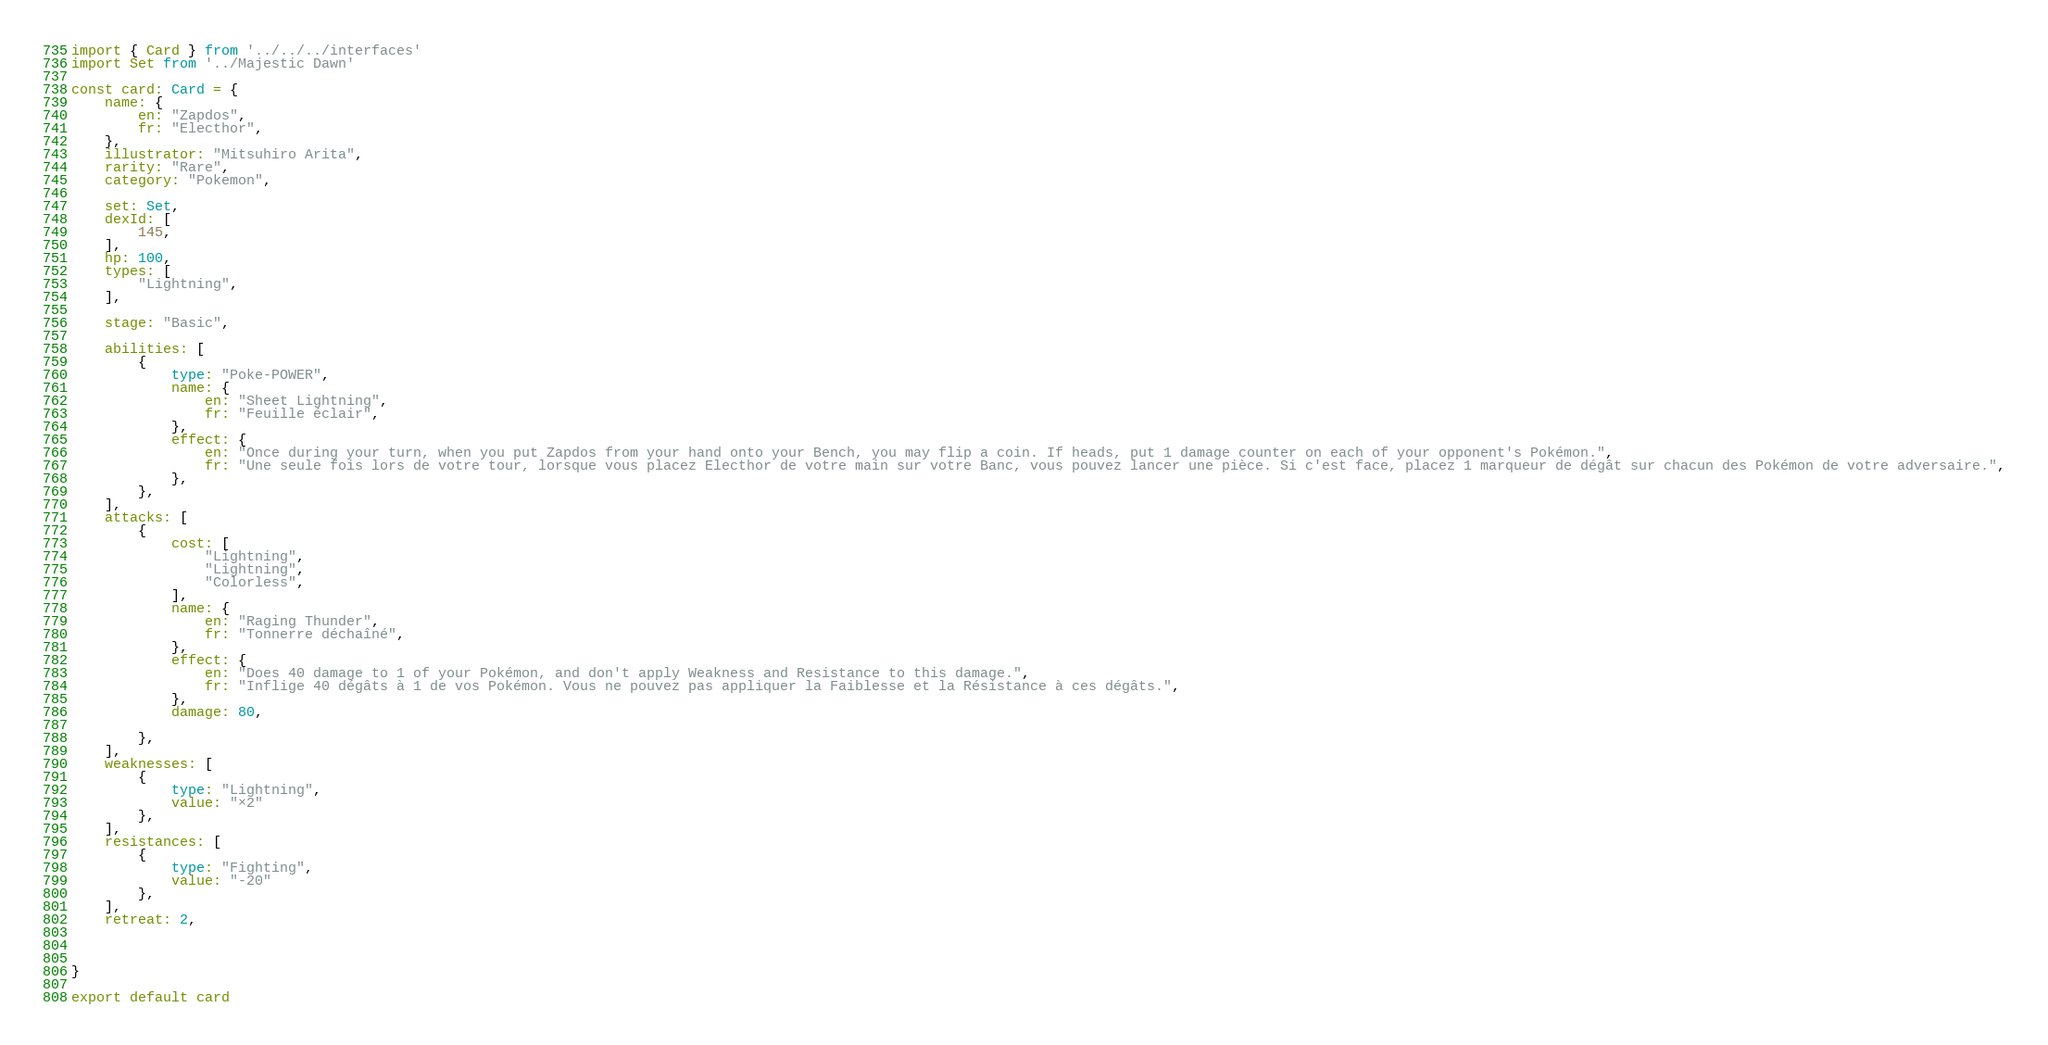Convert code to text. <code><loc_0><loc_0><loc_500><loc_500><_TypeScript_>import { Card } from '../../../interfaces'
import Set from '../Majestic Dawn'

const card: Card = {
	name: {
		en: "Zapdos",
		fr: "Electhor",
	},
	illustrator: "Mitsuhiro Arita",
	rarity: "Rare",
	category: "Pokemon",

	set: Set,
	dexId: [
		145,
	],
	hp: 100,
	types: [
		"Lightning",
	],

	stage: "Basic",

	abilities: [
		{
			type: "Poke-POWER",
			name: {
				en: "Sheet Lightning",
				fr: "Feuille éclair",
			},
			effect: {
				en: "Once during your turn, when you put Zapdos from your hand onto your Bench, you may flip a coin. If heads, put 1 damage counter on each of your opponent's Pokémon.",
				fr: "Une seule fois lors de votre tour, lorsque vous placez Electhor de votre main sur votre Banc, vous pouvez lancer une pièce. Si c'est face, placez 1 marqueur de dégât sur chacun des Pokémon de votre adversaire.",
			},
		},
	],
	attacks: [
		{
			cost: [
				"Lightning",
				"Lightning",
				"Colorless",
			],
			name: {
				en: "Raging Thunder",
				fr: "Tonnerre déchaîné",
			},
			effect: {
				en: "Does 40 damage to 1 of your Pokémon, and don't apply Weakness and Resistance to this damage.",
				fr: "Inflige 40 dégâts à 1 de vos Pokémon. Vous ne pouvez pas appliquer la Faiblesse et la Résistance à ces dégâts.",
			},
			damage: 80,

		},
	],
	weaknesses: [
		{
			type: "Lightning",
			value: "×2"
		},
	],
	resistances: [
		{
			type: "Fighting",
			value: "-20"
		},
	],
	retreat: 2,



}

export default card
</code> 